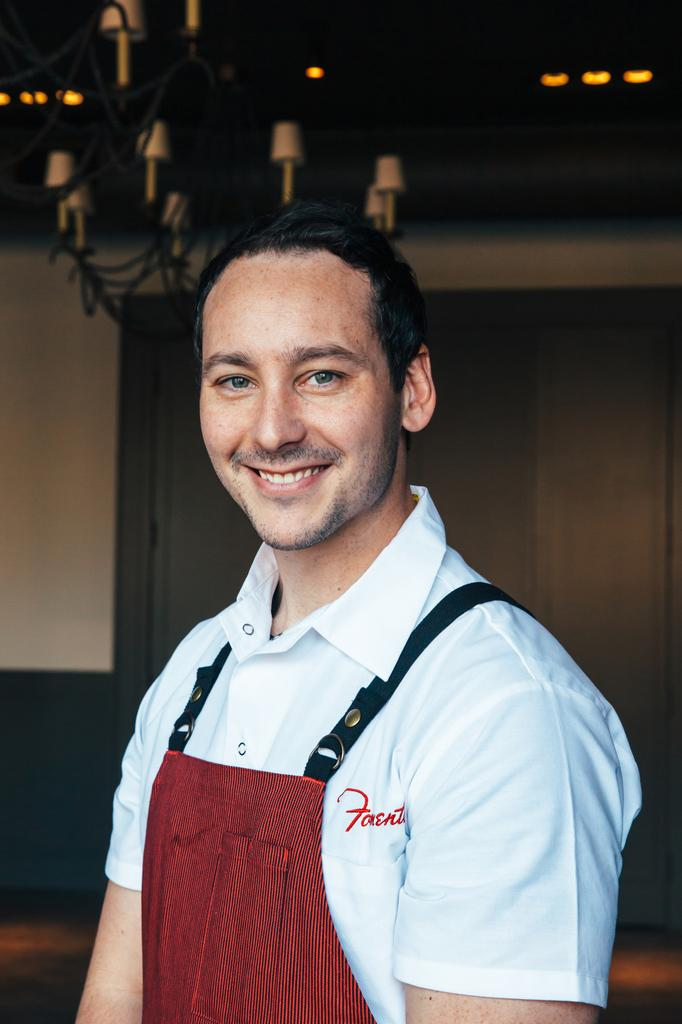Provide a one-sentence caption for the provided image. A man smiles for the camera in a red apron and white shirt with the partial name "Fonent" legible on it. 